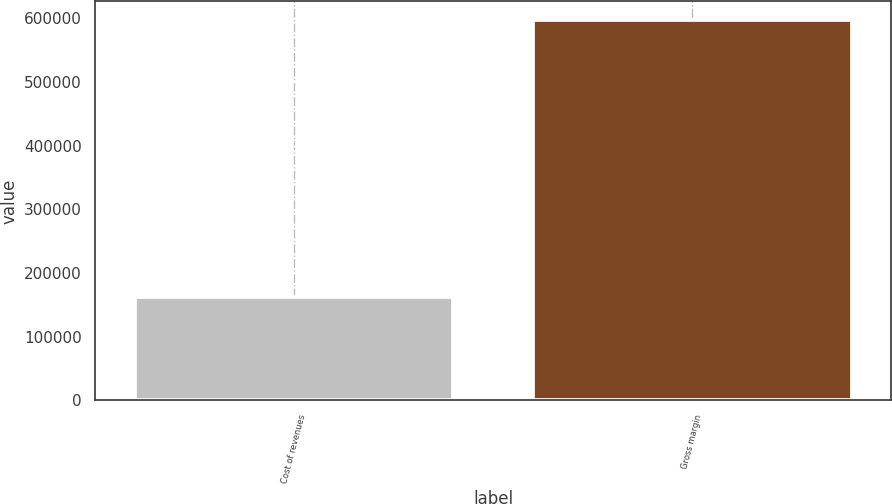Convert chart to OTSL. <chart><loc_0><loc_0><loc_500><loc_500><bar_chart><fcel>Cost of revenues<fcel>Gross margin<nl><fcel>162228<fcel>596535<nl></chart> 